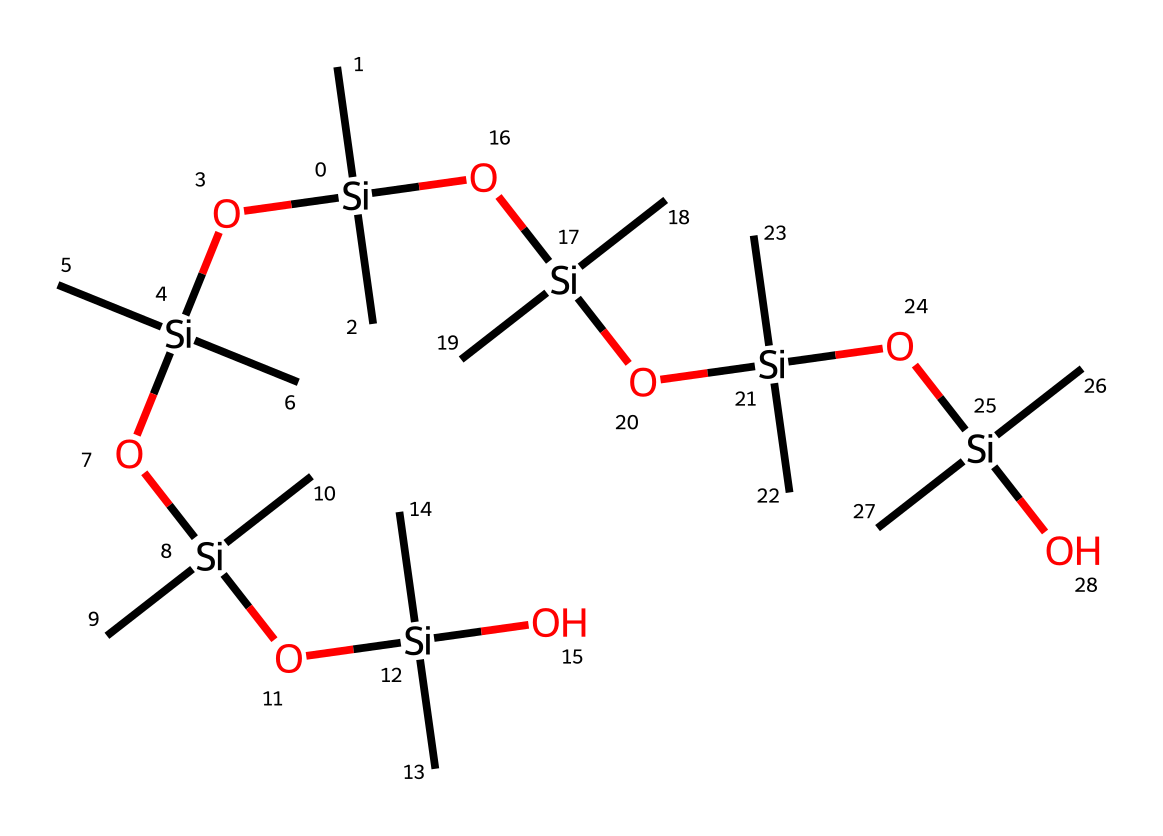What is the primary backbone of this polymer? The repeating units in the structure indicate that silicon atoms form the primary backbone of this polymer, as seen throughout the chain where silicon atoms are bonded to oxygen and carbon groups.
Answer: silicon How many oxygen atoms are present in the structure? By analyzing the structural representation, each silicon atom is bonded to at least one oxygen atom, and there are five silicone units with four additional oxygen atoms connected to them. Thus, counting them results in a total of four oxygen atoms in the main chain of the polymer.
Answer: four What type of polymer is represented by this structure? The presence of a silicon-oxygen backbone suggests that this is a silicone polymer, characterized by its incorporation of silicon and oxygen in the main chain, significantly used for encapsulating photovoltaic modules.
Answer: silicone How many silicone units are in this polymer? The structure clearly displays that there are a total of five distinct silicon units, each contributing to the overall chain of the polymer and accounting for its properties as a silicone-based encapsulant.
Answer: five What properties are typically enhanced by using silicone-based encapsulants in solar panels? Silicone-based encapsulants are known for their exceptional thermal stability and resistance to UV degradation, which enhances the durability and longevity of solar panels significantly when integrated into the photovoltaic module.
Answer: durability What type of bond connects silicon and oxygen in this polymer? The bonding between silicon and oxygen in silicone polymers is generally covalent; thus, examining the molecular structure indicates that covalent bonds are the primary linkages connecting these atoms throughout the polymer chain.
Answer: covalent 